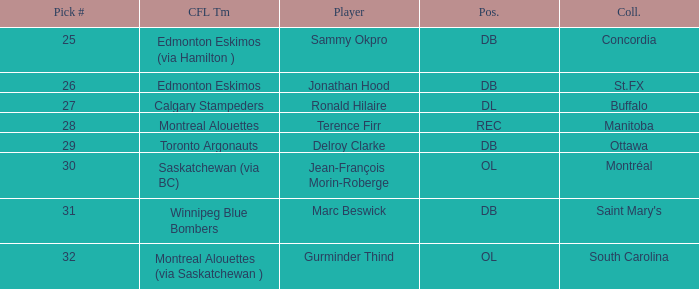Which College has a Pick # larger than 30, and a Position of ol? South Carolina. 